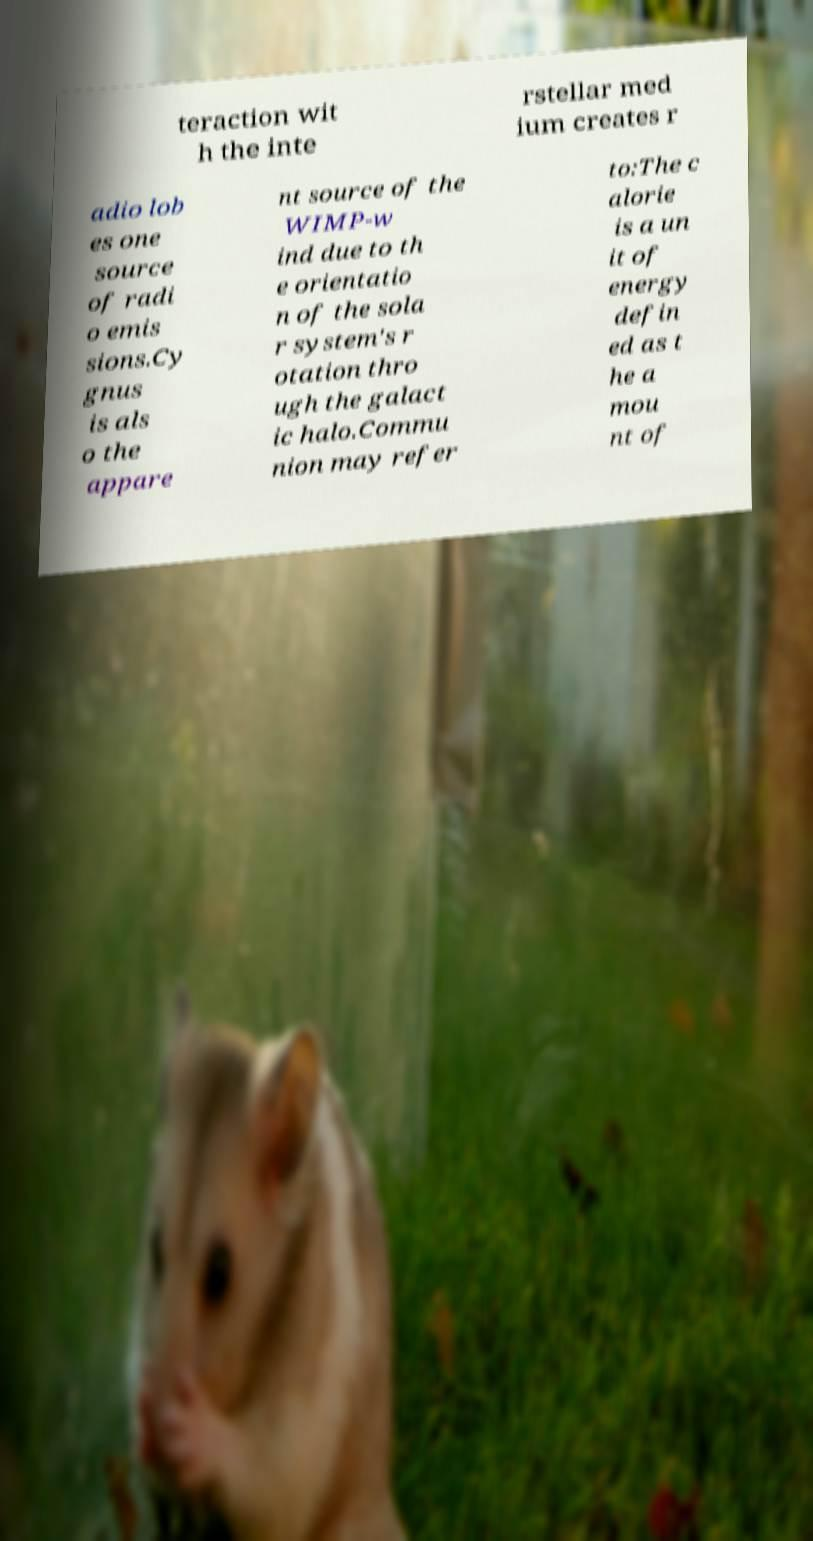Please identify and transcribe the text found in this image. teraction wit h the inte rstellar med ium creates r adio lob es one source of radi o emis sions.Cy gnus is als o the appare nt source of the WIMP-w ind due to th e orientatio n of the sola r system's r otation thro ugh the galact ic halo.Commu nion may refer to:The c alorie is a un it of energy defin ed as t he a mou nt of 